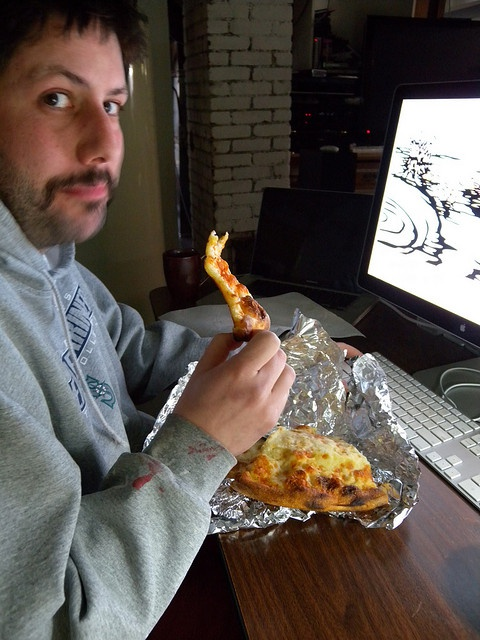Describe the objects in this image and their specific colors. I can see people in black, gray, darkgray, and maroon tones, tv in black, white, gray, and darkgray tones, laptop in black and gray tones, pizza in black, brown, maroon, and tan tones, and keyboard in black, darkgray, lightgray, and gray tones in this image. 